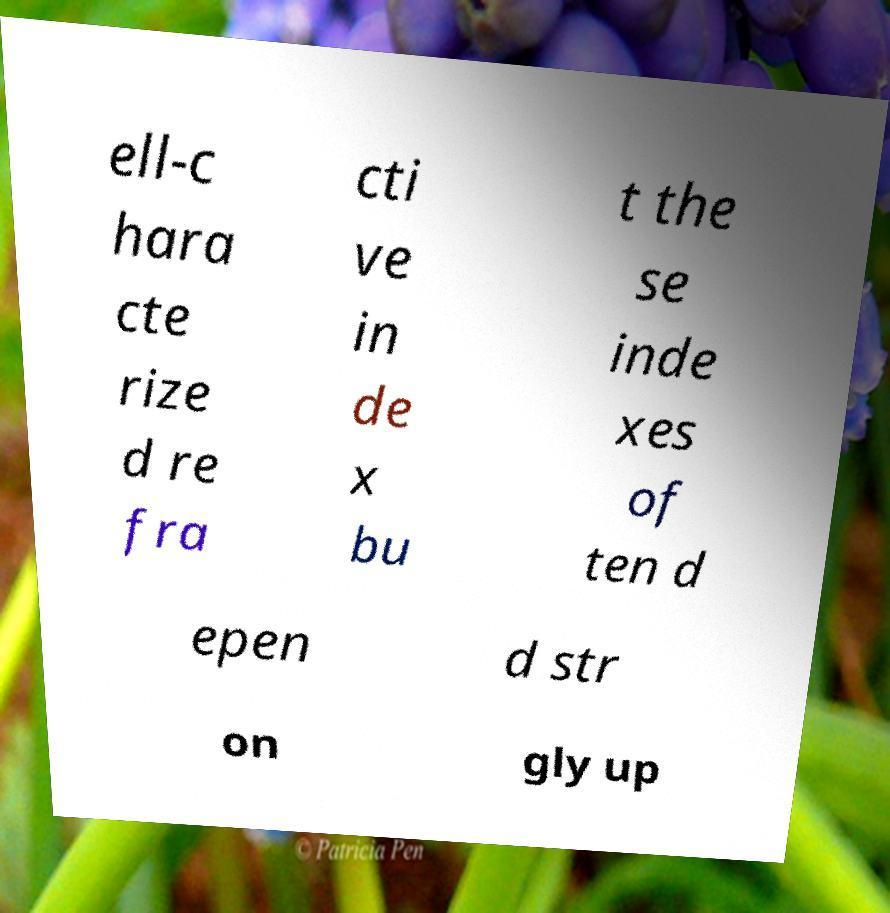Can you accurately transcribe the text from the provided image for me? ell-c hara cte rize d re fra cti ve in de x bu t the se inde xes of ten d epen d str on gly up 